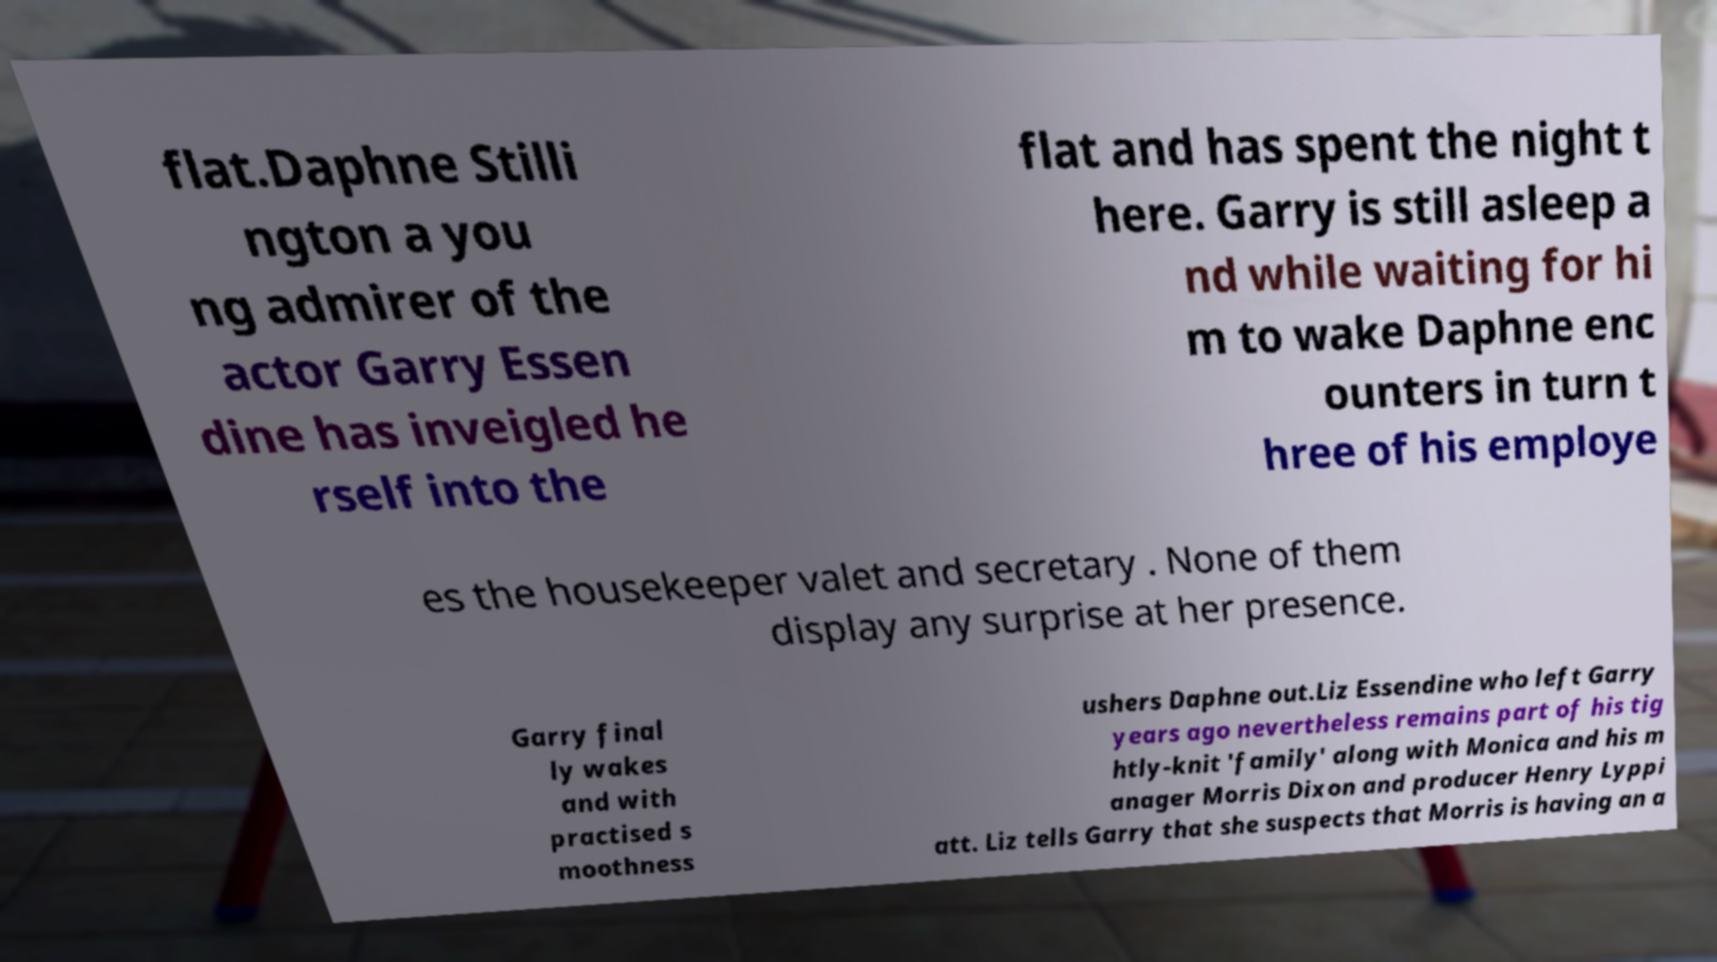Could you assist in decoding the text presented in this image and type it out clearly? flat.Daphne Stilli ngton a you ng admirer of the actor Garry Essen dine has inveigled he rself into the flat and has spent the night t here. Garry is still asleep a nd while waiting for hi m to wake Daphne enc ounters in turn t hree of his employe es the housekeeper valet and secretary . None of them display any surprise at her presence. Garry final ly wakes and with practised s moothness ushers Daphne out.Liz Essendine who left Garry years ago nevertheless remains part of his tig htly-knit 'family' along with Monica and his m anager Morris Dixon and producer Henry Lyppi att. Liz tells Garry that she suspects that Morris is having an a 